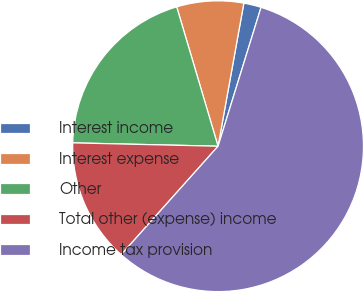Convert chart to OTSL. <chart><loc_0><loc_0><loc_500><loc_500><pie_chart><fcel>Interest income<fcel>Interest expense<fcel>Other<fcel>Total other (expense) income<fcel>Income tax provision<nl><fcel>1.94%<fcel>7.43%<fcel>20.04%<fcel>13.76%<fcel>56.83%<nl></chart> 